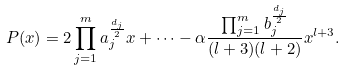Convert formula to latex. <formula><loc_0><loc_0><loc_500><loc_500>P ( x ) = 2 \prod _ { j = 1 } ^ { m } a _ { j } ^ { \frac { d _ { j } } { 2 } } x + \dots - \alpha \frac { \prod _ { j = 1 } ^ { m } b _ { j } ^ { \frac { d _ { j } } { 2 } } } { ( l + 3 ) ( l + 2 ) } x ^ { l + 3 } .</formula> 